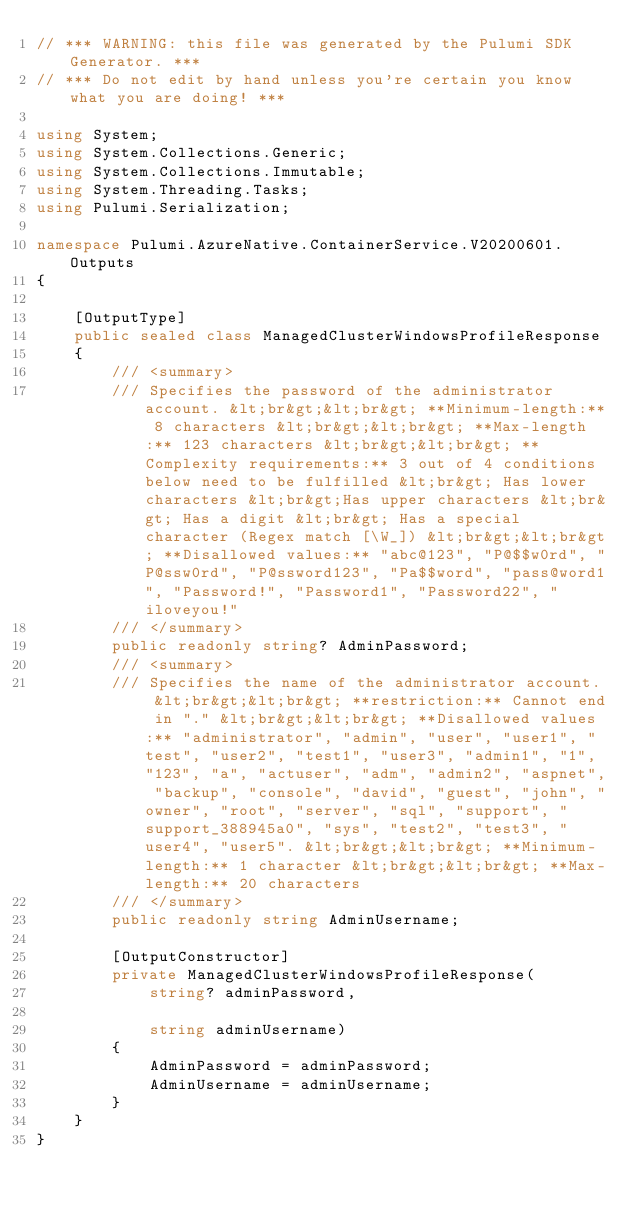<code> <loc_0><loc_0><loc_500><loc_500><_C#_>// *** WARNING: this file was generated by the Pulumi SDK Generator. ***
// *** Do not edit by hand unless you're certain you know what you are doing! ***

using System;
using System.Collections.Generic;
using System.Collections.Immutable;
using System.Threading.Tasks;
using Pulumi.Serialization;

namespace Pulumi.AzureNative.ContainerService.V20200601.Outputs
{

    [OutputType]
    public sealed class ManagedClusterWindowsProfileResponse
    {
        /// <summary>
        /// Specifies the password of the administrator account. &lt;br&gt;&lt;br&gt; **Minimum-length:** 8 characters &lt;br&gt;&lt;br&gt; **Max-length:** 123 characters &lt;br&gt;&lt;br&gt; **Complexity requirements:** 3 out of 4 conditions below need to be fulfilled &lt;br&gt; Has lower characters &lt;br&gt;Has upper characters &lt;br&gt; Has a digit &lt;br&gt; Has a special character (Regex match [\W_]) &lt;br&gt;&lt;br&gt; **Disallowed values:** "abc@123", "P@$$w0rd", "P@ssw0rd", "P@ssword123", "Pa$$word", "pass@word1", "Password!", "Password1", "Password22", "iloveyou!"
        /// </summary>
        public readonly string? AdminPassword;
        /// <summary>
        /// Specifies the name of the administrator account. &lt;br&gt;&lt;br&gt; **restriction:** Cannot end in "." &lt;br&gt;&lt;br&gt; **Disallowed values:** "administrator", "admin", "user", "user1", "test", "user2", "test1", "user3", "admin1", "1", "123", "a", "actuser", "adm", "admin2", "aspnet", "backup", "console", "david", "guest", "john", "owner", "root", "server", "sql", "support", "support_388945a0", "sys", "test2", "test3", "user4", "user5". &lt;br&gt;&lt;br&gt; **Minimum-length:** 1 character &lt;br&gt;&lt;br&gt; **Max-length:** 20 characters
        /// </summary>
        public readonly string AdminUsername;

        [OutputConstructor]
        private ManagedClusterWindowsProfileResponse(
            string? adminPassword,

            string adminUsername)
        {
            AdminPassword = adminPassword;
            AdminUsername = adminUsername;
        }
    }
}
</code> 